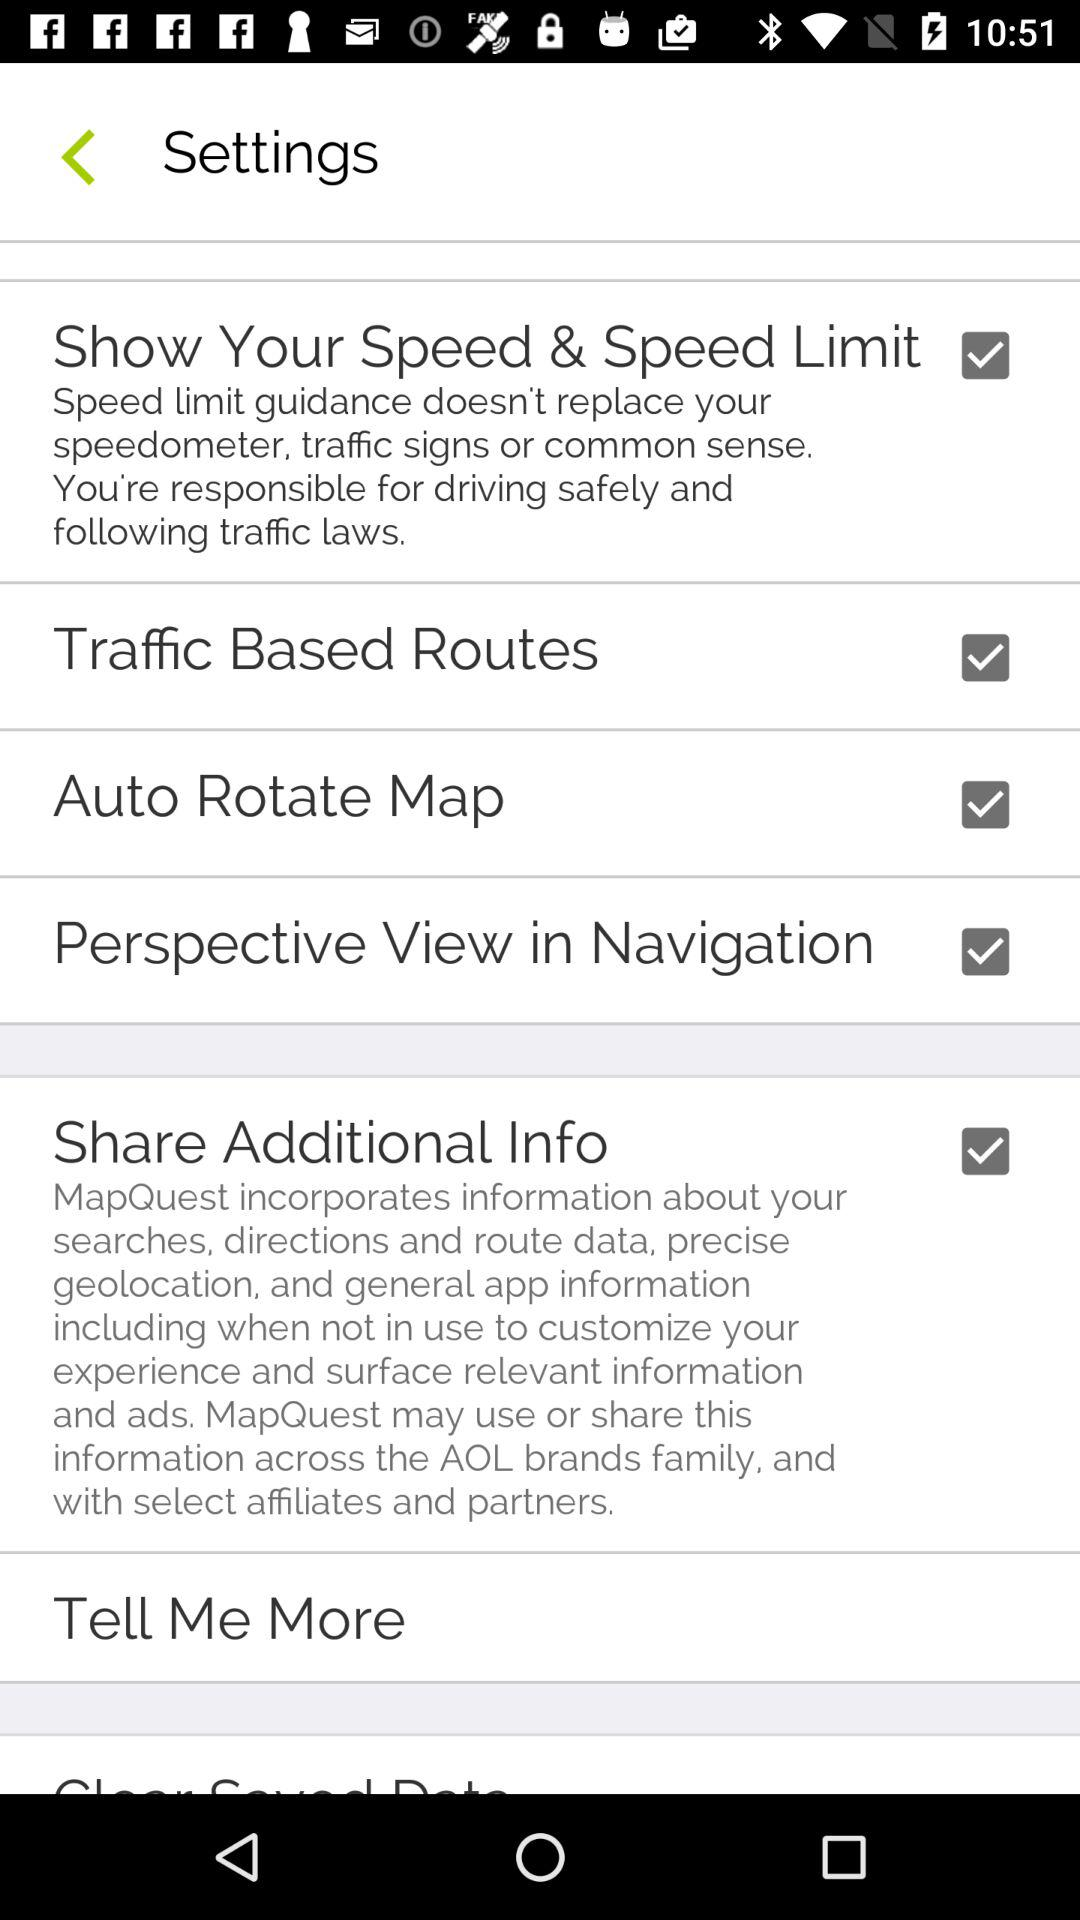What is the status of the "Traffic Based Routes"? The status is "on". 